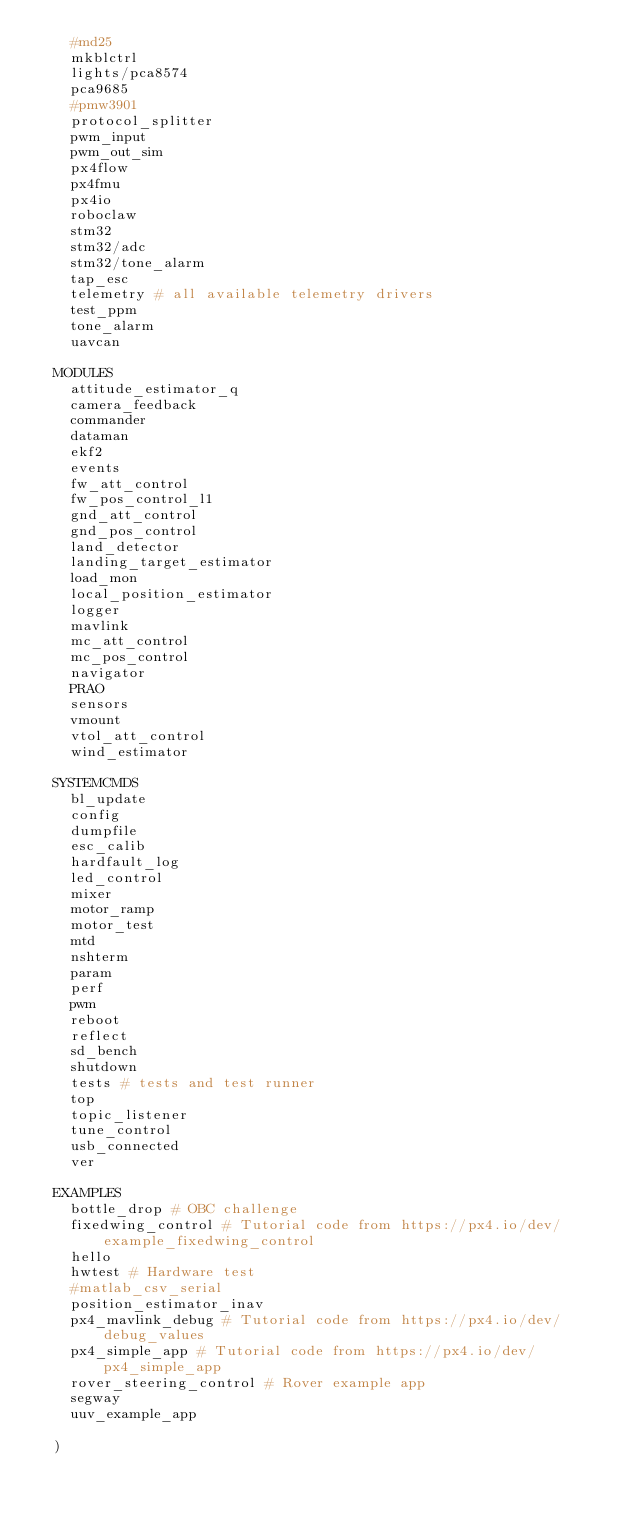Convert code to text. <code><loc_0><loc_0><loc_500><loc_500><_CMake_>		#md25
		mkblctrl
		lights/pca8574
		pca9685
		#pmw3901
		protocol_splitter
		pwm_input
		pwm_out_sim
		px4flow
		px4fmu
		px4io
		roboclaw
		stm32
		stm32/adc
		stm32/tone_alarm
		tap_esc
		telemetry # all available telemetry drivers
		test_ppm
		tone_alarm
		uavcan

	MODULES
		attitude_estimator_q
		camera_feedback
		commander
		dataman
		ekf2
		events
		fw_att_control
		fw_pos_control_l1
		gnd_att_control
		gnd_pos_control
		land_detector
		landing_target_estimator
		load_mon
		local_position_estimator
		logger
		mavlink
		mc_att_control
		mc_pos_control
		navigator
		PRAO
		sensors
		vmount
		vtol_att_control
		wind_estimator

	SYSTEMCMDS
		bl_update
		config
		dumpfile
		esc_calib
		hardfault_log
		led_control
		mixer
		motor_ramp
		motor_test
		mtd
		nshterm
		param
		perf
		pwm
		reboot
		reflect
		sd_bench
		shutdown
		tests # tests and test runner
		top
		topic_listener
		tune_control
		usb_connected
		ver

	EXAMPLES
		bottle_drop # OBC challenge
		fixedwing_control # Tutorial code from https://px4.io/dev/example_fixedwing_control
		hello
		hwtest # Hardware test
		#matlab_csv_serial
		position_estimator_inav
		px4_mavlink_debug # Tutorial code from https://px4.io/dev/debug_values
		px4_simple_app # Tutorial code from https://px4.io/dev/px4_simple_app
		rover_steering_control # Rover example app
		segway
		uuv_example_app

	)
</code> 